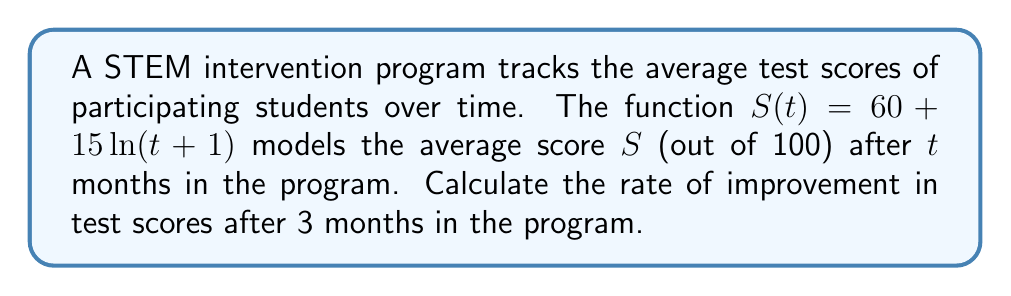What is the answer to this math problem? To find the rate of improvement in test scores after 3 months, we need to calculate the derivative of $S(t)$ and evaluate it at $t=3$. This will give us the instantaneous rate of change at that point.

Step 1: Find the derivative of $S(t)$
$$S(t) = 60 + 15\ln(t+1)$$
$$S'(t) = 15 \cdot \frac{d}{dt}[\ln(t+1)]$$
$$S'(t) = 15 \cdot \frac{1}{t+1}$$

Step 2: Evaluate $S'(t)$ at $t=3$
$$S'(3) = 15 \cdot \frac{1}{3+1} = 15 \cdot \frac{1}{4} = \frac{15}{4} = 3.75$$

Therefore, after 3 months in the program, the rate of improvement in test scores is 3.75 points per month.
Answer: $3.75$ points per month 